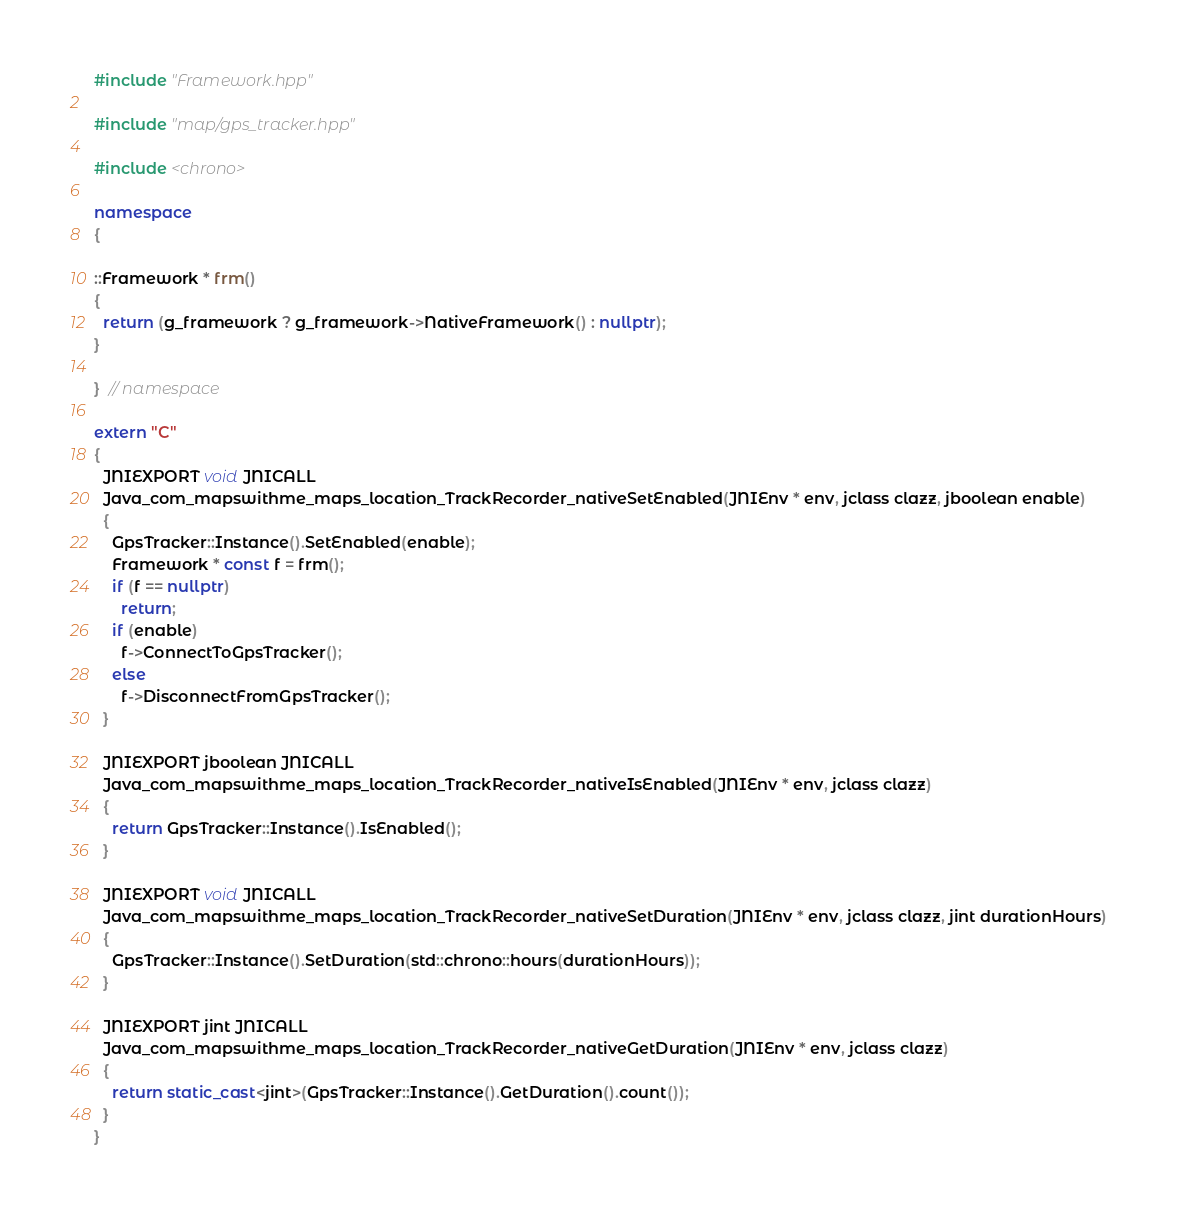<code> <loc_0><loc_0><loc_500><loc_500><_C++_>#include "Framework.hpp"

#include "map/gps_tracker.hpp"

#include <chrono>

namespace
{

::Framework * frm()
{
  return (g_framework ? g_framework->NativeFramework() : nullptr);
}

}  // namespace

extern "C"
{
  JNIEXPORT void JNICALL
  Java_com_mapswithme_maps_location_TrackRecorder_nativeSetEnabled(JNIEnv * env, jclass clazz, jboolean enable)
  {
    GpsTracker::Instance().SetEnabled(enable);
    Framework * const f = frm();
    if (f == nullptr)
      return;
    if (enable)
      f->ConnectToGpsTracker();
    else
      f->DisconnectFromGpsTracker();
  }

  JNIEXPORT jboolean JNICALL
  Java_com_mapswithme_maps_location_TrackRecorder_nativeIsEnabled(JNIEnv * env, jclass clazz)
  {
    return GpsTracker::Instance().IsEnabled();
  }

  JNIEXPORT void JNICALL
  Java_com_mapswithme_maps_location_TrackRecorder_nativeSetDuration(JNIEnv * env, jclass clazz, jint durationHours)
  {
    GpsTracker::Instance().SetDuration(std::chrono::hours(durationHours));
  }

  JNIEXPORT jint JNICALL
  Java_com_mapswithme_maps_location_TrackRecorder_nativeGetDuration(JNIEnv * env, jclass clazz)
  {
    return static_cast<jint>(GpsTracker::Instance().GetDuration().count());
  }
}
</code> 